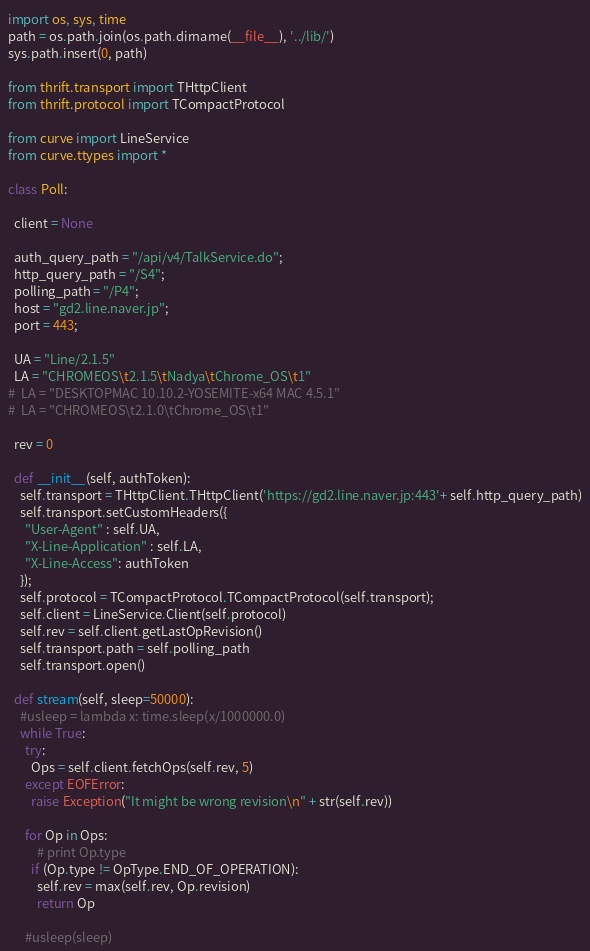<code> <loc_0><loc_0><loc_500><loc_500><_Python_>import os, sys, time
path = os.path.join(os.path.dirname(__file__), '../lib/')
sys.path.insert(0, path)

from thrift.transport import THttpClient
from thrift.protocol import TCompactProtocol

from curve import LineService
from curve.ttypes import *

class Poll:

  client = None

  auth_query_path = "/api/v4/TalkService.do";
  http_query_path = "/S4";
  polling_path = "/P4";
  host = "gd2.line.naver.jp";
  port = 443;

  UA = "Line/2.1.5"
  LA = "CHROMEOS\t2.1.5\tNadya\tChrome_OS\t1"
#  LA = "DESKTOPMAC 10.10.2-YOSEMITE-x64 MAC 4.5.1"
#  LA = "CHROMEOS\t2.1.0\tChrome_OS\t1"

  rev = 0

  def __init__(self, authToken):
    self.transport = THttpClient.THttpClient('https://gd2.line.naver.jp:443'+ self.http_query_path)
    self.transport.setCustomHeaders({
      "User-Agent" : self.UA,
      "X-Line-Application" : self.LA,
      "X-Line-Access": authToken
    });
    self.protocol = TCompactProtocol.TCompactProtocol(self.transport);
    self.client = LineService.Client(self.protocol)
    self.rev = self.client.getLastOpRevision()
    self.transport.path = self.polling_path
    self.transport.open()

  def stream(self, sleep=50000):
    #usleep = lambda x: time.sleep(x/1000000.0)
    while True:
      try:
        Ops = self.client.fetchOps(self.rev, 5)
      except EOFError:
        raise Exception("It might be wrong revision\n" + str(self.rev))

      for Op in Ops:
          # print Op.type
        if (Op.type != OpType.END_OF_OPERATION):
          self.rev = max(self.rev, Op.revision)
          return Op

      #usleep(sleep)
</code> 